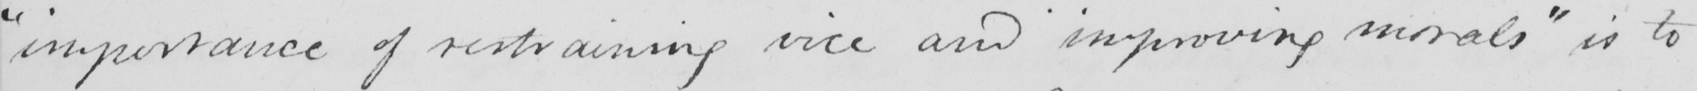Can you tell me what this handwritten text says? " importance of restraining vice and improving morals "  is to 